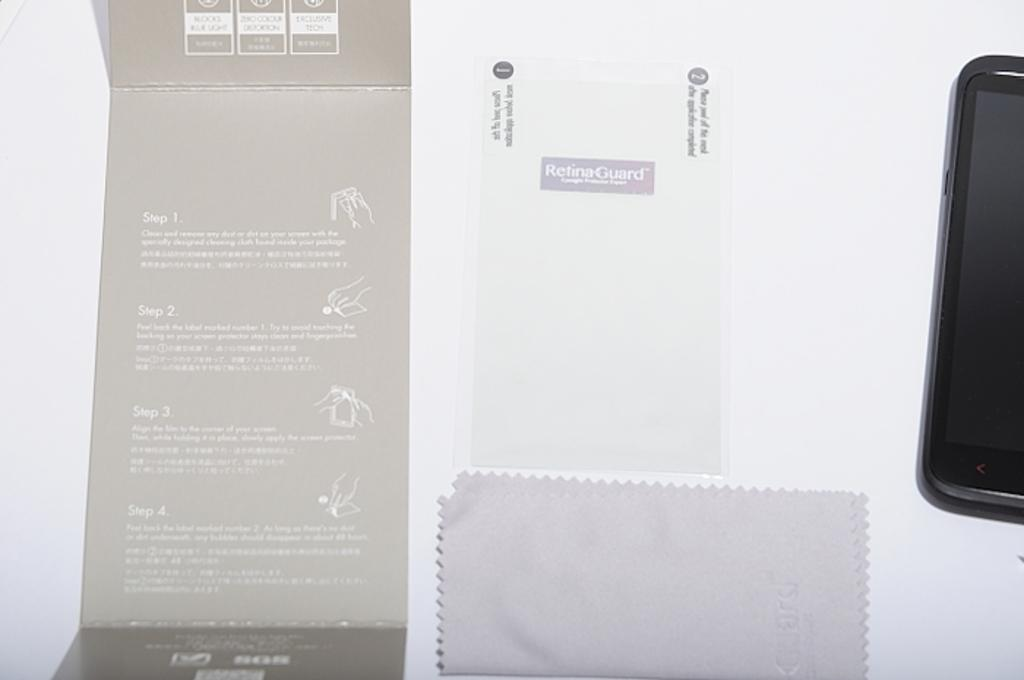<image>
Render a clear and concise summary of the photo. A Samsung smart phone is powered off and laying sideways. 